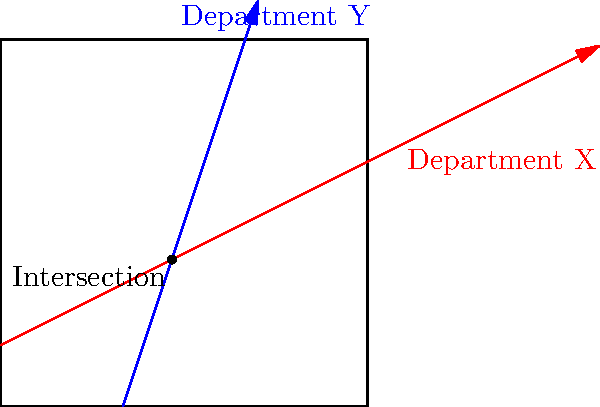In a frustrating attempt to navigate the labyrinthine bureaucracy, you encounter a diagram representing the jurisdictions of two government departments. Department X's jurisdiction is represented by the red line $y = \frac{1}{2}x + 1$, while Department Y's is represented by the blue line $y = 3x - 6$. At which point do these departments' jurisdictions overlap, forcing you to deal with both simultaneously? To find the intersection point, we need to solve the system of equations:

1) For Department X: $y = \frac{1}{2}x + 1$
2) For Department Y: $y = 3x - 6$

Let's solve this step-by-step:

1) Set the equations equal to each other:
   $\frac{1}{2}x + 1 = 3x - 6$

2) Subtract $\frac{1}{2}x$ from both sides:
   $1 = \frac{5}{2}x - 6$

3) Add 6 to both sides:
   $7 = \frac{5}{2}x$

4) Multiply both sides by $\frac{2}{5}$:
   $\frac{14}{5} = x$

5) Substitute this x-value into either original equation. Let's use Department X's:
   $y = \frac{1}{2}(\frac{14}{5}) + 1$
   $y = \frac{7}{5} + 1 = \frac{7}{5} + \frac{5}{5} = \frac{12}{5}$

Therefore, the intersection point is $(\frac{14}{5}, \frac{12}{5})$ or $(2.8, 2.4)$ in decimal form.
Answer: $(\frac{14}{5}, \frac{12}{5})$ 